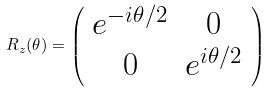<formula> <loc_0><loc_0><loc_500><loc_500>R _ { z } ( \theta ) = \left ( \begin{array} { c c } e ^ { - i \theta / 2 } & 0 \\ 0 & e ^ { i \theta / 2 } \end{array} \right )</formula> 